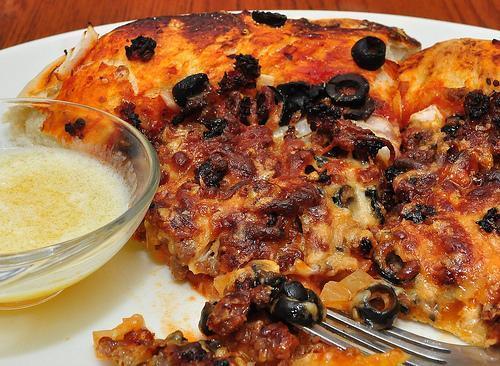How many forks?
Give a very brief answer. 1. 